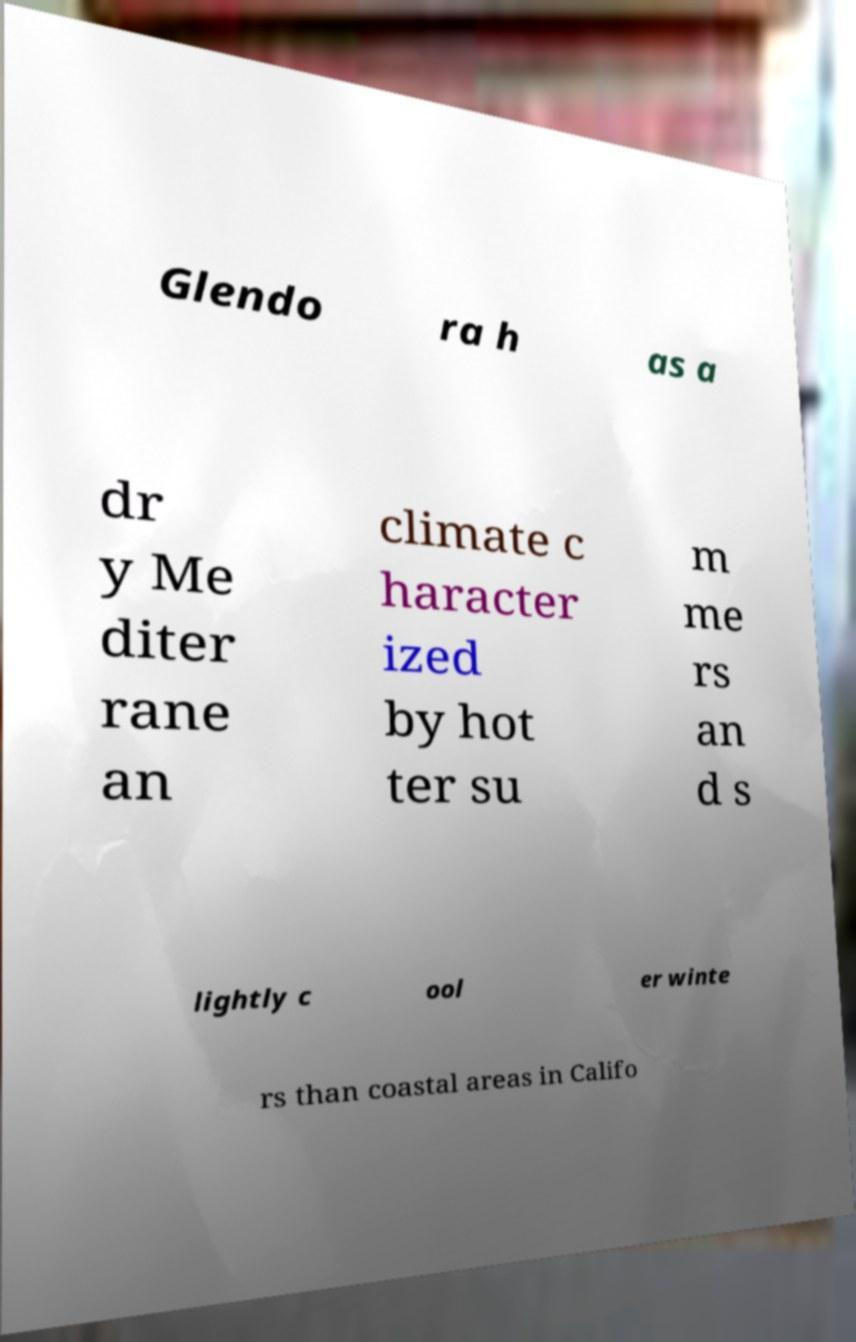What messages or text are displayed in this image? I need them in a readable, typed format. Glendo ra h as a dr y Me diter rane an climate c haracter ized by hot ter su m me rs an d s lightly c ool er winte rs than coastal areas in Califo 